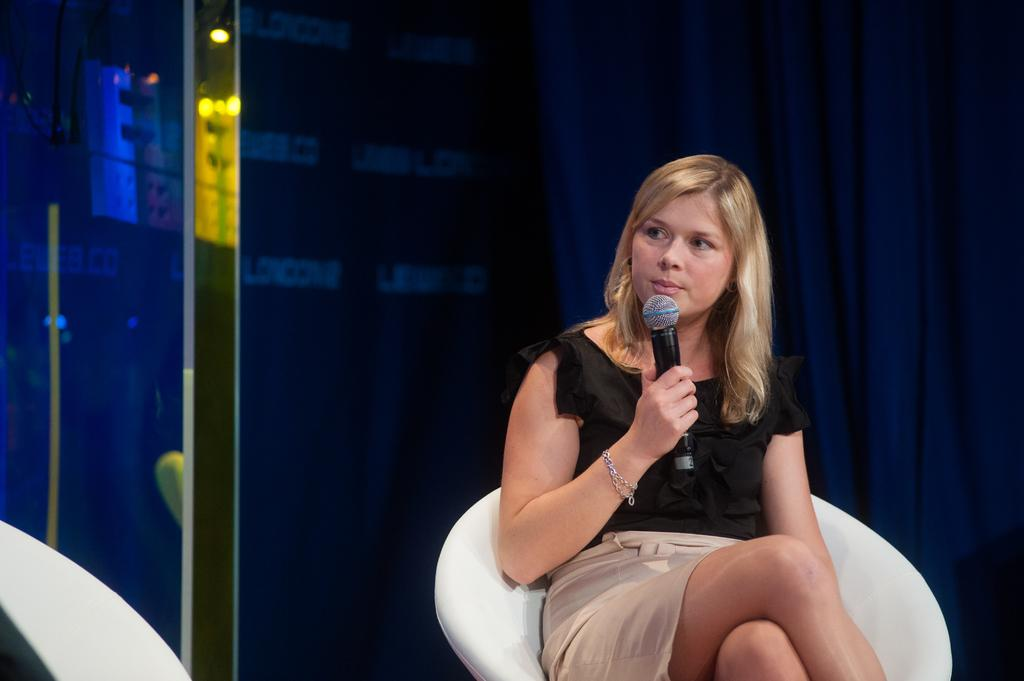Who is the main subject in the image? There is a lady in the image. What is the lady doing in the image? The lady is sitting in a chair and holding a mic in her right hand. Can you describe any accessories the lady is wearing? There is a bracelet on her right hand. What can be seen in the background of the image? There is a blue curtain in the background of the image. What type of sack is visible on the floor in the image? There is no sack present on the floor in the image. Can you describe the texture of the coach the lady is sitting on? There is no coach present in the image; the lady is sitting in a chair. 